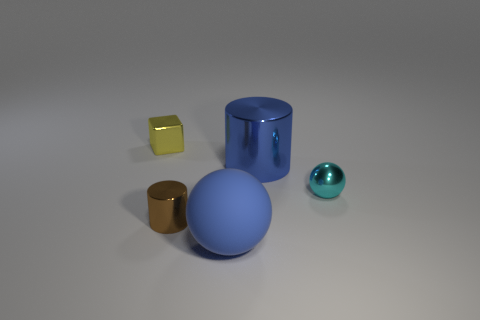What shape is the tiny cyan object?
Make the answer very short. Sphere. The metal thing that is behind the cyan metallic sphere and to the right of the small metal block has what shape?
Ensure brevity in your answer.  Cylinder. What color is the tiny cylinder that is made of the same material as the small ball?
Ensure brevity in your answer.  Brown. What is the shape of the large blue thing that is behind the cylinder in front of the large blue object that is on the right side of the large blue rubber object?
Make the answer very short. Cylinder. The blue metallic cylinder is what size?
Your answer should be compact. Large. What shape is the blue object that is the same material as the yellow thing?
Ensure brevity in your answer.  Cylinder. Are there fewer blue cylinders right of the big metal cylinder than brown shiny blocks?
Your answer should be compact. No. There is a tiny shiny thing on the right side of the blue matte sphere; what color is it?
Your answer should be very brief. Cyan. There is a object that is the same color as the large sphere; what is its material?
Provide a succinct answer. Metal. Are there any large blue matte objects that have the same shape as the tiny yellow metal thing?
Your response must be concise. No. 